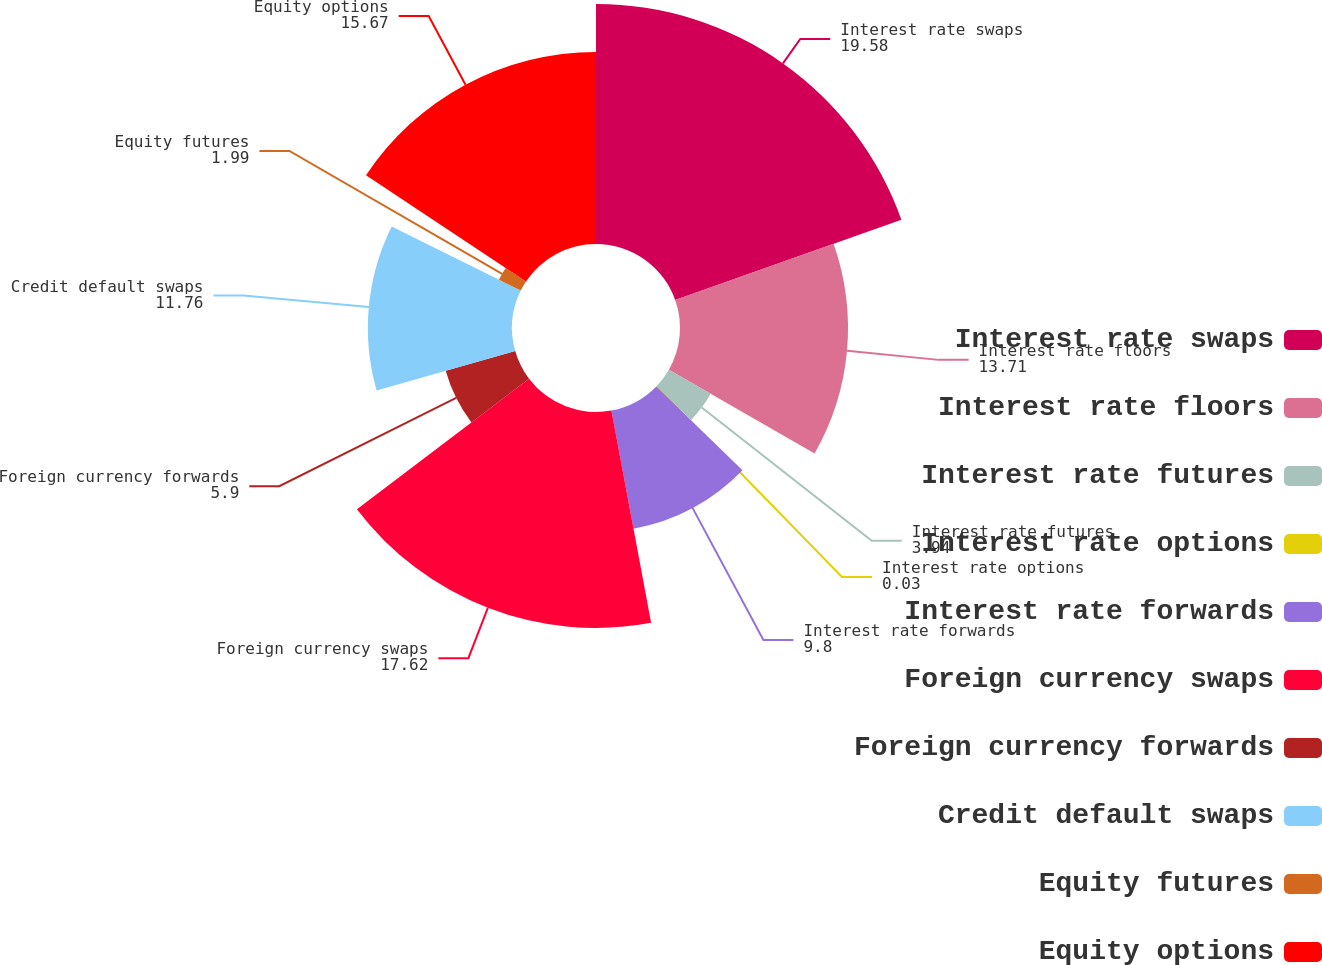Convert chart. <chart><loc_0><loc_0><loc_500><loc_500><pie_chart><fcel>Interest rate swaps<fcel>Interest rate floors<fcel>Interest rate futures<fcel>Interest rate options<fcel>Interest rate forwards<fcel>Foreign currency swaps<fcel>Foreign currency forwards<fcel>Credit default swaps<fcel>Equity futures<fcel>Equity options<nl><fcel>19.58%<fcel>13.71%<fcel>3.94%<fcel>0.03%<fcel>9.8%<fcel>17.62%<fcel>5.9%<fcel>11.76%<fcel>1.99%<fcel>15.67%<nl></chart> 